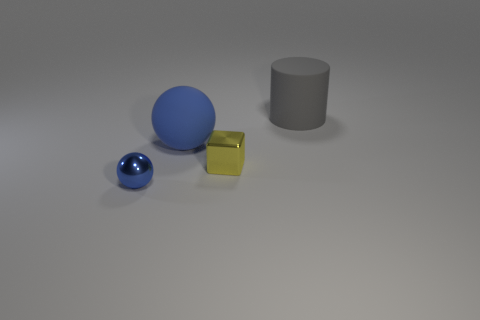What number of shiny objects are big blue things or small brown cylinders?
Offer a very short reply. 0. Is the material of the blue sphere in front of the big blue rubber object the same as the tiny thing that is right of the big ball?
Your answer should be compact. Yes. What is the color of the large thing that is the same material as the big cylinder?
Ensure brevity in your answer.  Blue. Are there more large gray rubber things in front of the tiny yellow object than large rubber balls that are in front of the small sphere?
Ensure brevity in your answer.  No. Is there a tiny red metallic cube?
Offer a very short reply. No. What is the material of the big object that is the same color as the tiny sphere?
Keep it short and to the point. Rubber. What number of objects are blue shiny cylinders or big gray rubber cylinders?
Give a very brief answer. 1. Are there any big rubber blocks that have the same color as the tiny cube?
Offer a very short reply. No. How many blue balls are on the right side of the tiny object that is to the left of the small block?
Make the answer very short. 1. Are there more tiny blue metallic objects than small shiny objects?
Your answer should be compact. No. 